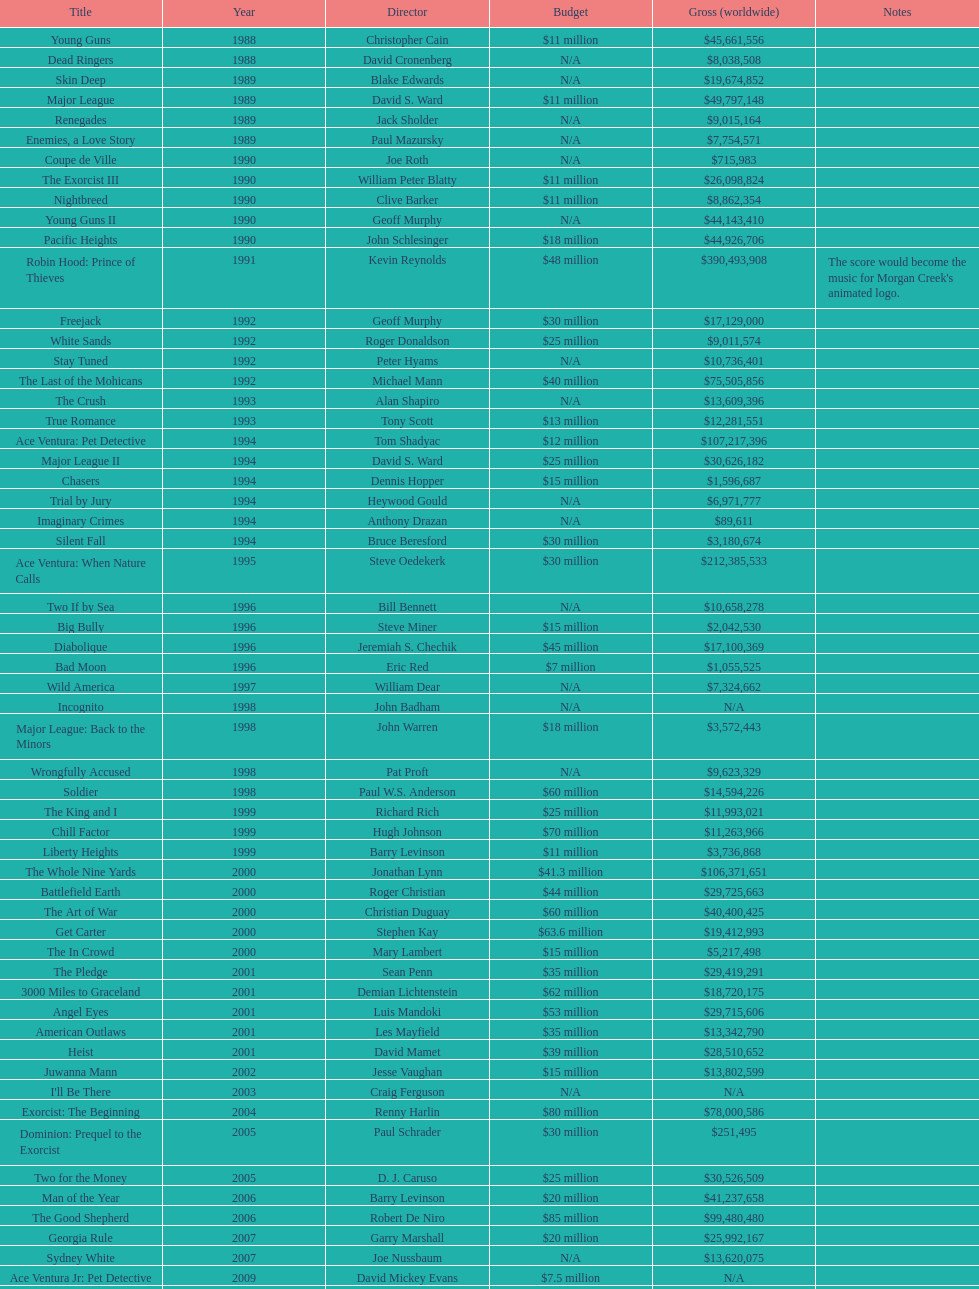What is the number of films directed by david s. ward? 2. 